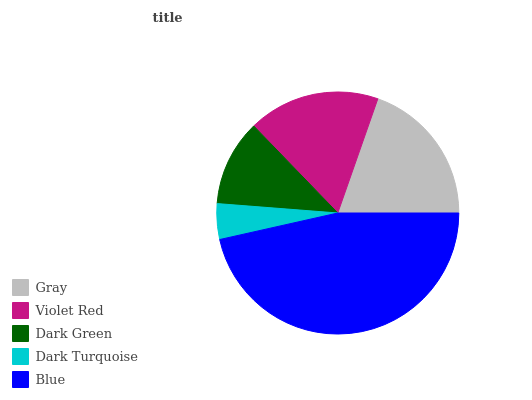Is Dark Turquoise the minimum?
Answer yes or no. Yes. Is Blue the maximum?
Answer yes or no. Yes. Is Violet Red the minimum?
Answer yes or no. No. Is Violet Red the maximum?
Answer yes or no. No. Is Gray greater than Violet Red?
Answer yes or no. Yes. Is Violet Red less than Gray?
Answer yes or no. Yes. Is Violet Red greater than Gray?
Answer yes or no. No. Is Gray less than Violet Red?
Answer yes or no. No. Is Violet Red the high median?
Answer yes or no. Yes. Is Violet Red the low median?
Answer yes or no. Yes. Is Dark Turquoise the high median?
Answer yes or no. No. Is Gray the low median?
Answer yes or no. No. 